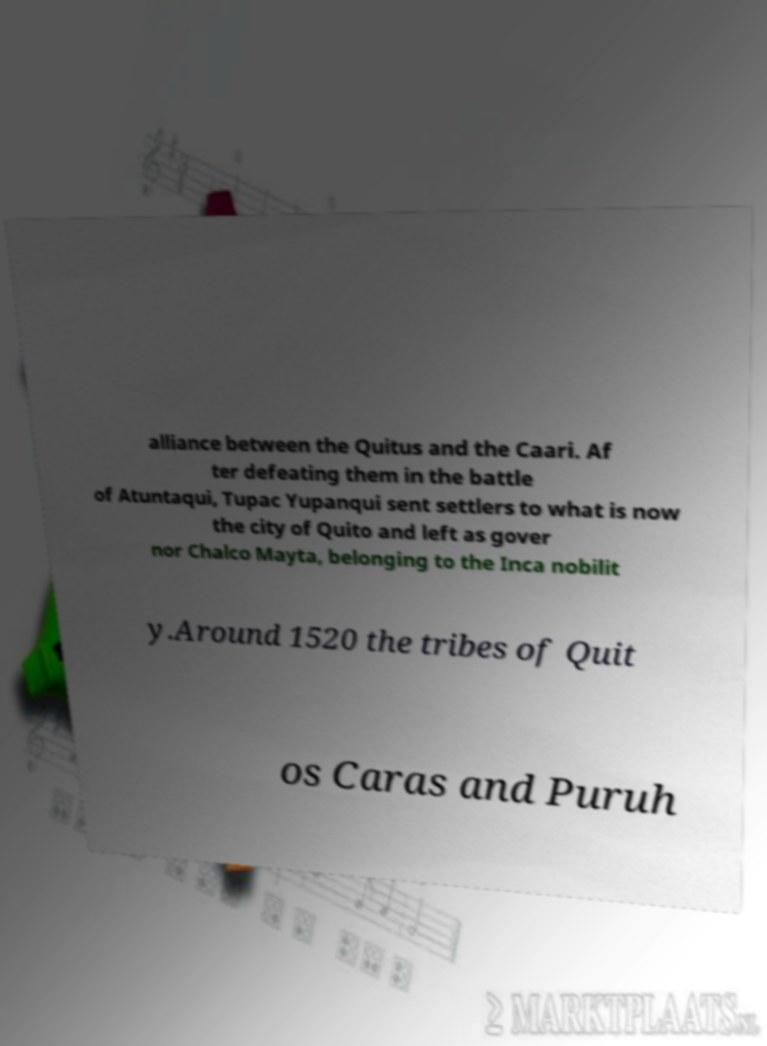I need the written content from this picture converted into text. Can you do that? alliance between the Quitus and the Caari. Af ter defeating them in the battle of Atuntaqui, Tupac Yupanqui sent settlers to what is now the city of Quito and left as gover nor Chalco Mayta, belonging to the Inca nobilit y.Around 1520 the tribes of Quit os Caras and Puruh 